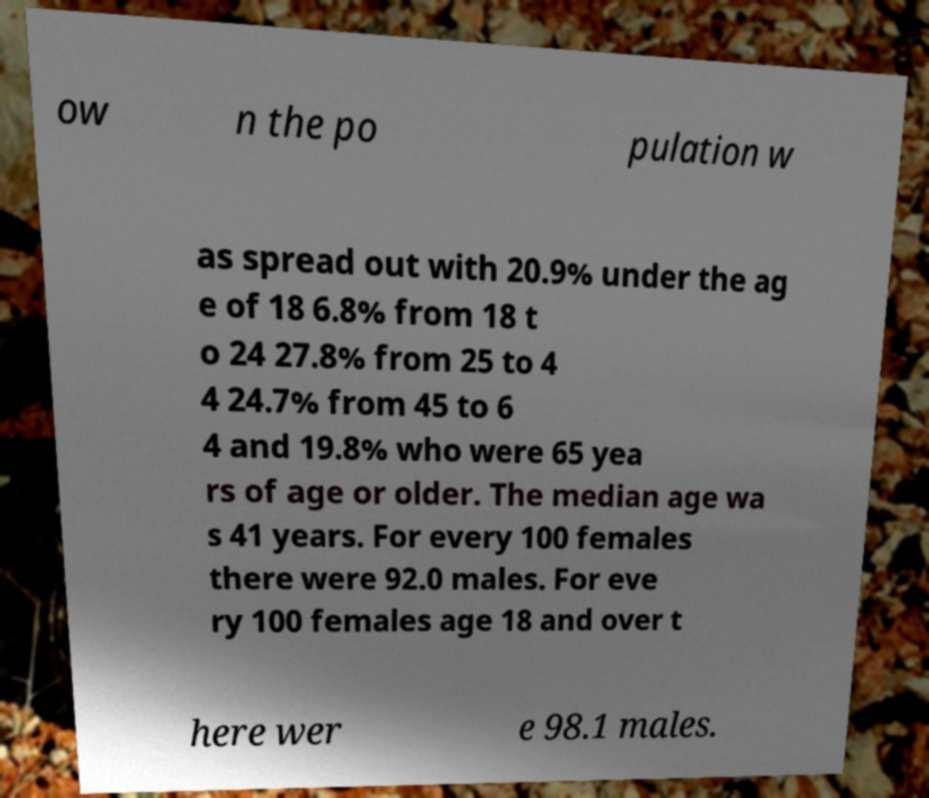Please read and relay the text visible in this image. What does it say? ow n the po pulation w as spread out with 20.9% under the ag e of 18 6.8% from 18 t o 24 27.8% from 25 to 4 4 24.7% from 45 to 6 4 and 19.8% who were 65 yea rs of age or older. The median age wa s 41 years. For every 100 females there were 92.0 males. For eve ry 100 females age 18 and over t here wer e 98.1 males. 